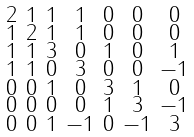Convert formula to latex. <formula><loc_0><loc_0><loc_500><loc_500>\begin{smallmatrix} 2 & 1 & 1 & 1 & 0 & 0 & 0 \\ 1 & 2 & 1 & 1 & 0 & 0 & 0 \\ 1 & 1 & 3 & 0 & 1 & 0 & 1 \\ 1 & 1 & 0 & 3 & 0 & 0 & - 1 \\ 0 & 0 & 1 & 0 & 3 & 1 & 0 \\ 0 & 0 & 0 & 0 & 1 & 3 & - 1 \\ 0 & 0 & 1 & - 1 & 0 & - 1 & 3 \end{smallmatrix}</formula> 